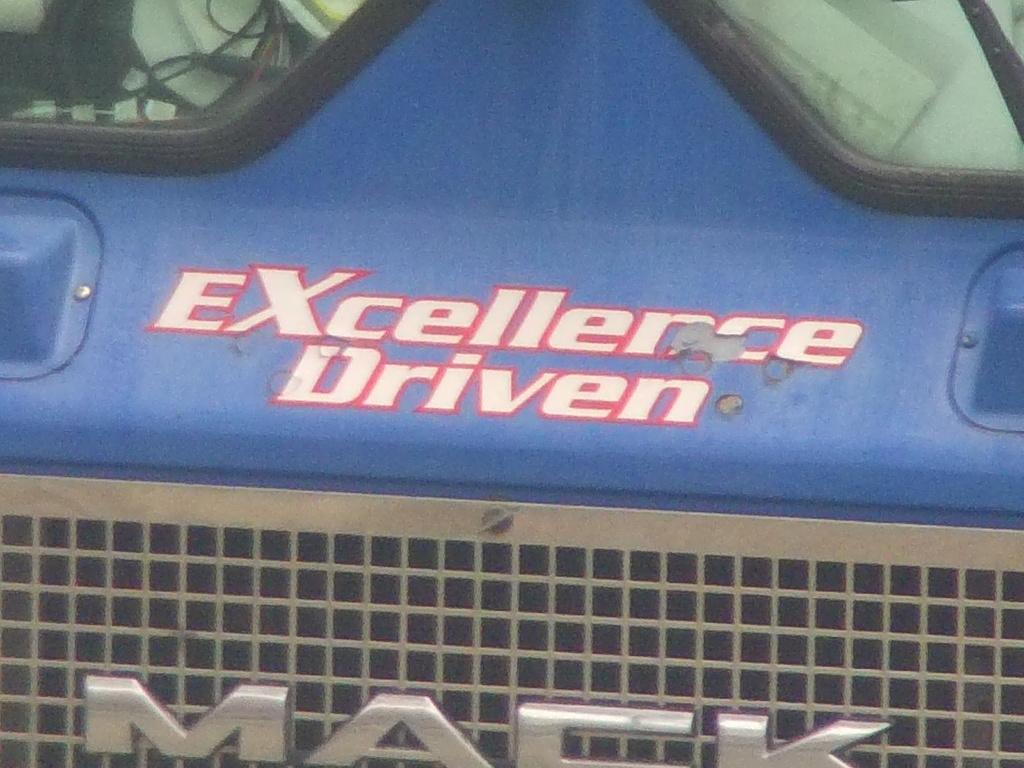What type of vehicle is shown in the image? The image shows the front part of a vehicle, but the specific type cannot be determined from the provided facts. Can you describe the visible features of the vehicle in the image? Unfortunately, the provided facts do not give any details about the visible features of the vehicle. What type of pancake is being served by the band in the image? There is no pancake or band present in the image; it only shows the front part of a vehicle. 